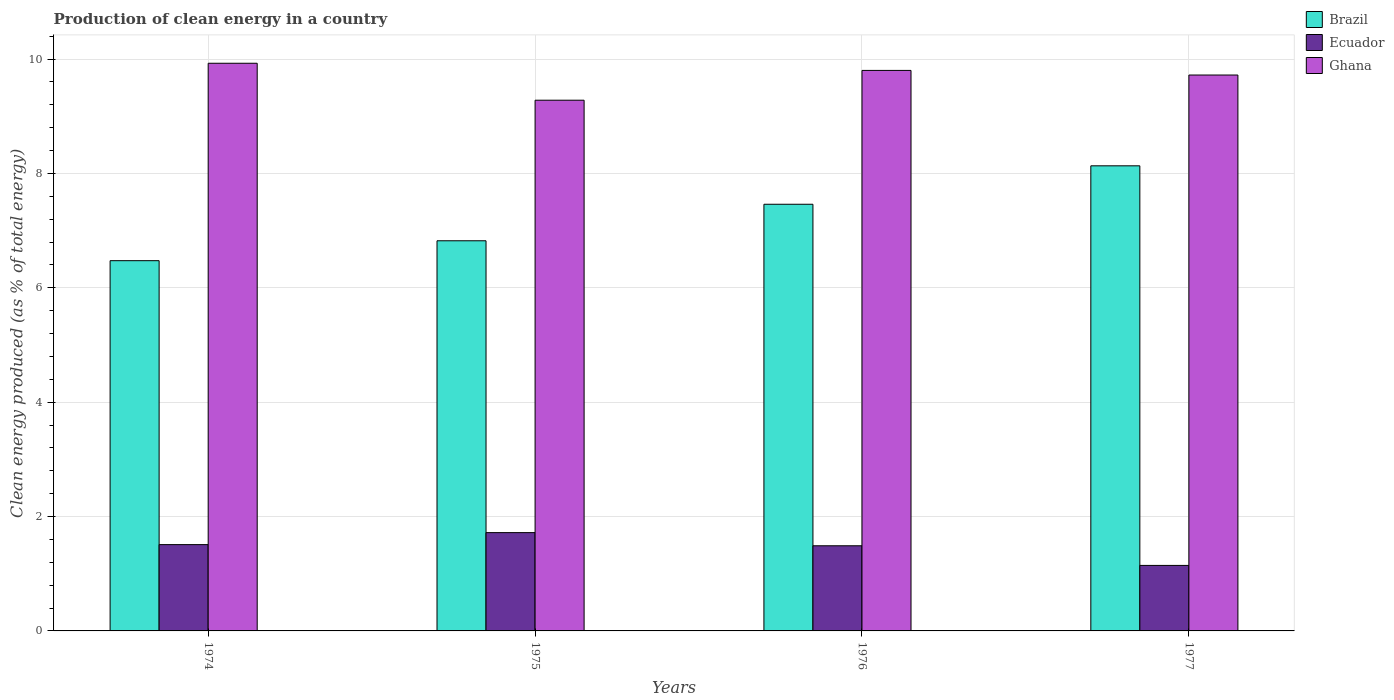How many groups of bars are there?
Ensure brevity in your answer.  4. Are the number of bars on each tick of the X-axis equal?
Your answer should be compact. Yes. How many bars are there on the 1st tick from the left?
Your response must be concise. 3. How many bars are there on the 1st tick from the right?
Provide a succinct answer. 3. What is the label of the 2nd group of bars from the left?
Your response must be concise. 1975. In how many cases, is the number of bars for a given year not equal to the number of legend labels?
Ensure brevity in your answer.  0. What is the percentage of clean energy produced in Ecuador in 1976?
Keep it short and to the point. 1.49. Across all years, what is the maximum percentage of clean energy produced in Ghana?
Your answer should be compact. 9.93. Across all years, what is the minimum percentage of clean energy produced in Ecuador?
Your answer should be compact. 1.15. In which year was the percentage of clean energy produced in Brazil maximum?
Your answer should be compact. 1977. In which year was the percentage of clean energy produced in Brazil minimum?
Offer a terse response. 1974. What is the total percentage of clean energy produced in Ecuador in the graph?
Give a very brief answer. 5.86. What is the difference between the percentage of clean energy produced in Ecuador in 1975 and that in 1977?
Keep it short and to the point. 0.57. What is the difference between the percentage of clean energy produced in Brazil in 1975 and the percentage of clean energy produced in Ghana in 1976?
Keep it short and to the point. -2.98. What is the average percentage of clean energy produced in Ghana per year?
Provide a succinct answer. 9.68. In the year 1975, what is the difference between the percentage of clean energy produced in Ecuador and percentage of clean energy produced in Ghana?
Provide a short and direct response. -7.56. In how many years, is the percentage of clean energy produced in Ecuador greater than 7.6 %?
Give a very brief answer. 0. What is the ratio of the percentage of clean energy produced in Brazil in 1976 to that in 1977?
Ensure brevity in your answer.  0.92. Is the difference between the percentage of clean energy produced in Ecuador in 1974 and 1977 greater than the difference between the percentage of clean energy produced in Ghana in 1974 and 1977?
Give a very brief answer. Yes. What is the difference between the highest and the second highest percentage of clean energy produced in Ecuador?
Ensure brevity in your answer.  0.21. What is the difference between the highest and the lowest percentage of clean energy produced in Ghana?
Offer a terse response. 0.65. In how many years, is the percentage of clean energy produced in Brazil greater than the average percentage of clean energy produced in Brazil taken over all years?
Make the answer very short. 2. What does the 3rd bar from the left in 1975 represents?
Offer a very short reply. Ghana. What does the 2nd bar from the right in 1976 represents?
Provide a succinct answer. Ecuador. Is it the case that in every year, the sum of the percentage of clean energy produced in Ecuador and percentage of clean energy produced in Brazil is greater than the percentage of clean energy produced in Ghana?
Your response must be concise. No. How many years are there in the graph?
Your answer should be compact. 4. Are the values on the major ticks of Y-axis written in scientific E-notation?
Keep it short and to the point. No. Does the graph contain any zero values?
Your answer should be compact. No. Where does the legend appear in the graph?
Offer a very short reply. Top right. What is the title of the graph?
Offer a terse response. Production of clean energy in a country. Does "Mali" appear as one of the legend labels in the graph?
Your answer should be compact. No. What is the label or title of the X-axis?
Give a very brief answer. Years. What is the label or title of the Y-axis?
Provide a short and direct response. Clean energy produced (as % of total energy). What is the Clean energy produced (as % of total energy) of Brazil in 1974?
Provide a succinct answer. 6.47. What is the Clean energy produced (as % of total energy) in Ecuador in 1974?
Make the answer very short. 1.51. What is the Clean energy produced (as % of total energy) of Ghana in 1974?
Provide a short and direct response. 9.93. What is the Clean energy produced (as % of total energy) of Brazil in 1975?
Provide a succinct answer. 6.82. What is the Clean energy produced (as % of total energy) in Ecuador in 1975?
Provide a succinct answer. 1.72. What is the Clean energy produced (as % of total energy) in Ghana in 1975?
Your response must be concise. 9.28. What is the Clean energy produced (as % of total energy) in Brazil in 1976?
Offer a very short reply. 7.46. What is the Clean energy produced (as % of total energy) of Ecuador in 1976?
Provide a short and direct response. 1.49. What is the Clean energy produced (as % of total energy) in Ghana in 1976?
Your response must be concise. 9.8. What is the Clean energy produced (as % of total energy) in Brazil in 1977?
Give a very brief answer. 8.13. What is the Clean energy produced (as % of total energy) in Ecuador in 1977?
Give a very brief answer. 1.15. What is the Clean energy produced (as % of total energy) of Ghana in 1977?
Provide a succinct answer. 9.72. Across all years, what is the maximum Clean energy produced (as % of total energy) of Brazil?
Make the answer very short. 8.13. Across all years, what is the maximum Clean energy produced (as % of total energy) in Ecuador?
Your answer should be compact. 1.72. Across all years, what is the maximum Clean energy produced (as % of total energy) of Ghana?
Your answer should be compact. 9.93. Across all years, what is the minimum Clean energy produced (as % of total energy) in Brazil?
Your answer should be very brief. 6.47. Across all years, what is the minimum Clean energy produced (as % of total energy) in Ecuador?
Your response must be concise. 1.15. Across all years, what is the minimum Clean energy produced (as % of total energy) in Ghana?
Provide a short and direct response. 9.28. What is the total Clean energy produced (as % of total energy) in Brazil in the graph?
Your answer should be compact. 28.89. What is the total Clean energy produced (as % of total energy) of Ecuador in the graph?
Offer a very short reply. 5.86. What is the total Clean energy produced (as % of total energy) of Ghana in the graph?
Your answer should be compact. 38.73. What is the difference between the Clean energy produced (as % of total energy) in Brazil in 1974 and that in 1975?
Give a very brief answer. -0.35. What is the difference between the Clean energy produced (as % of total energy) in Ecuador in 1974 and that in 1975?
Offer a terse response. -0.21. What is the difference between the Clean energy produced (as % of total energy) in Ghana in 1974 and that in 1975?
Offer a very short reply. 0.65. What is the difference between the Clean energy produced (as % of total energy) in Brazil in 1974 and that in 1976?
Offer a terse response. -0.99. What is the difference between the Clean energy produced (as % of total energy) in Ecuador in 1974 and that in 1976?
Provide a succinct answer. 0.02. What is the difference between the Clean energy produced (as % of total energy) in Ghana in 1974 and that in 1976?
Offer a very short reply. 0.13. What is the difference between the Clean energy produced (as % of total energy) in Brazil in 1974 and that in 1977?
Provide a succinct answer. -1.66. What is the difference between the Clean energy produced (as % of total energy) in Ecuador in 1974 and that in 1977?
Keep it short and to the point. 0.36. What is the difference between the Clean energy produced (as % of total energy) in Ghana in 1974 and that in 1977?
Your answer should be compact. 0.21. What is the difference between the Clean energy produced (as % of total energy) in Brazil in 1975 and that in 1976?
Keep it short and to the point. -0.64. What is the difference between the Clean energy produced (as % of total energy) of Ecuador in 1975 and that in 1976?
Your answer should be very brief. 0.23. What is the difference between the Clean energy produced (as % of total energy) in Ghana in 1975 and that in 1976?
Your response must be concise. -0.52. What is the difference between the Clean energy produced (as % of total energy) of Brazil in 1975 and that in 1977?
Provide a succinct answer. -1.31. What is the difference between the Clean energy produced (as % of total energy) of Ecuador in 1975 and that in 1977?
Your answer should be compact. 0.57. What is the difference between the Clean energy produced (as % of total energy) in Ghana in 1975 and that in 1977?
Provide a short and direct response. -0.44. What is the difference between the Clean energy produced (as % of total energy) of Brazil in 1976 and that in 1977?
Provide a succinct answer. -0.67. What is the difference between the Clean energy produced (as % of total energy) of Ecuador in 1976 and that in 1977?
Keep it short and to the point. 0.34. What is the difference between the Clean energy produced (as % of total energy) in Ghana in 1976 and that in 1977?
Provide a succinct answer. 0.08. What is the difference between the Clean energy produced (as % of total energy) in Brazil in 1974 and the Clean energy produced (as % of total energy) in Ecuador in 1975?
Keep it short and to the point. 4.75. What is the difference between the Clean energy produced (as % of total energy) in Brazil in 1974 and the Clean energy produced (as % of total energy) in Ghana in 1975?
Offer a very short reply. -2.81. What is the difference between the Clean energy produced (as % of total energy) of Ecuador in 1974 and the Clean energy produced (as % of total energy) of Ghana in 1975?
Make the answer very short. -7.77. What is the difference between the Clean energy produced (as % of total energy) of Brazil in 1974 and the Clean energy produced (as % of total energy) of Ecuador in 1976?
Your answer should be compact. 4.99. What is the difference between the Clean energy produced (as % of total energy) in Brazil in 1974 and the Clean energy produced (as % of total energy) in Ghana in 1976?
Offer a terse response. -3.33. What is the difference between the Clean energy produced (as % of total energy) of Ecuador in 1974 and the Clean energy produced (as % of total energy) of Ghana in 1976?
Your answer should be compact. -8.29. What is the difference between the Clean energy produced (as % of total energy) in Brazil in 1974 and the Clean energy produced (as % of total energy) in Ecuador in 1977?
Offer a terse response. 5.33. What is the difference between the Clean energy produced (as % of total energy) in Brazil in 1974 and the Clean energy produced (as % of total energy) in Ghana in 1977?
Provide a short and direct response. -3.25. What is the difference between the Clean energy produced (as % of total energy) of Ecuador in 1974 and the Clean energy produced (as % of total energy) of Ghana in 1977?
Offer a very short reply. -8.21. What is the difference between the Clean energy produced (as % of total energy) in Brazil in 1975 and the Clean energy produced (as % of total energy) in Ecuador in 1976?
Offer a very short reply. 5.33. What is the difference between the Clean energy produced (as % of total energy) in Brazil in 1975 and the Clean energy produced (as % of total energy) in Ghana in 1976?
Give a very brief answer. -2.98. What is the difference between the Clean energy produced (as % of total energy) of Ecuador in 1975 and the Clean energy produced (as % of total energy) of Ghana in 1976?
Offer a terse response. -8.08. What is the difference between the Clean energy produced (as % of total energy) of Brazil in 1975 and the Clean energy produced (as % of total energy) of Ecuador in 1977?
Your response must be concise. 5.68. What is the difference between the Clean energy produced (as % of total energy) in Brazil in 1975 and the Clean energy produced (as % of total energy) in Ghana in 1977?
Keep it short and to the point. -2.9. What is the difference between the Clean energy produced (as % of total energy) of Ecuador in 1975 and the Clean energy produced (as % of total energy) of Ghana in 1977?
Your answer should be very brief. -8. What is the difference between the Clean energy produced (as % of total energy) in Brazil in 1976 and the Clean energy produced (as % of total energy) in Ecuador in 1977?
Make the answer very short. 6.31. What is the difference between the Clean energy produced (as % of total energy) of Brazil in 1976 and the Clean energy produced (as % of total energy) of Ghana in 1977?
Your response must be concise. -2.26. What is the difference between the Clean energy produced (as % of total energy) in Ecuador in 1976 and the Clean energy produced (as % of total energy) in Ghana in 1977?
Your answer should be compact. -8.23. What is the average Clean energy produced (as % of total energy) in Brazil per year?
Your answer should be compact. 7.22. What is the average Clean energy produced (as % of total energy) in Ecuador per year?
Your answer should be very brief. 1.47. What is the average Clean energy produced (as % of total energy) in Ghana per year?
Ensure brevity in your answer.  9.68. In the year 1974, what is the difference between the Clean energy produced (as % of total energy) in Brazil and Clean energy produced (as % of total energy) in Ecuador?
Your response must be concise. 4.96. In the year 1974, what is the difference between the Clean energy produced (as % of total energy) of Brazil and Clean energy produced (as % of total energy) of Ghana?
Ensure brevity in your answer.  -3.45. In the year 1974, what is the difference between the Clean energy produced (as % of total energy) in Ecuador and Clean energy produced (as % of total energy) in Ghana?
Offer a terse response. -8.42. In the year 1975, what is the difference between the Clean energy produced (as % of total energy) of Brazil and Clean energy produced (as % of total energy) of Ecuador?
Offer a very short reply. 5.1. In the year 1975, what is the difference between the Clean energy produced (as % of total energy) in Brazil and Clean energy produced (as % of total energy) in Ghana?
Give a very brief answer. -2.46. In the year 1975, what is the difference between the Clean energy produced (as % of total energy) in Ecuador and Clean energy produced (as % of total energy) in Ghana?
Your answer should be very brief. -7.56. In the year 1976, what is the difference between the Clean energy produced (as % of total energy) in Brazil and Clean energy produced (as % of total energy) in Ecuador?
Your response must be concise. 5.97. In the year 1976, what is the difference between the Clean energy produced (as % of total energy) of Brazil and Clean energy produced (as % of total energy) of Ghana?
Ensure brevity in your answer.  -2.34. In the year 1976, what is the difference between the Clean energy produced (as % of total energy) of Ecuador and Clean energy produced (as % of total energy) of Ghana?
Keep it short and to the point. -8.31. In the year 1977, what is the difference between the Clean energy produced (as % of total energy) of Brazil and Clean energy produced (as % of total energy) of Ecuador?
Keep it short and to the point. 6.99. In the year 1977, what is the difference between the Clean energy produced (as % of total energy) in Brazil and Clean energy produced (as % of total energy) in Ghana?
Provide a succinct answer. -1.59. In the year 1977, what is the difference between the Clean energy produced (as % of total energy) of Ecuador and Clean energy produced (as % of total energy) of Ghana?
Give a very brief answer. -8.57. What is the ratio of the Clean energy produced (as % of total energy) of Brazil in 1974 to that in 1975?
Offer a terse response. 0.95. What is the ratio of the Clean energy produced (as % of total energy) in Ecuador in 1974 to that in 1975?
Your answer should be compact. 0.88. What is the ratio of the Clean energy produced (as % of total energy) of Ghana in 1974 to that in 1975?
Make the answer very short. 1.07. What is the ratio of the Clean energy produced (as % of total energy) in Brazil in 1974 to that in 1976?
Keep it short and to the point. 0.87. What is the ratio of the Clean energy produced (as % of total energy) in Ecuador in 1974 to that in 1976?
Give a very brief answer. 1.01. What is the ratio of the Clean energy produced (as % of total energy) in Ghana in 1974 to that in 1976?
Keep it short and to the point. 1.01. What is the ratio of the Clean energy produced (as % of total energy) of Brazil in 1974 to that in 1977?
Ensure brevity in your answer.  0.8. What is the ratio of the Clean energy produced (as % of total energy) in Ecuador in 1974 to that in 1977?
Provide a succinct answer. 1.32. What is the ratio of the Clean energy produced (as % of total energy) of Ghana in 1974 to that in 1977?
Your response must be concise. 1.02. What is the ratio of the Clean energy produced (as % of total energy) in Brazil in 1975 to that in 1976?
Offer a terse response. 0.91. What is the ratio of the Clean energy produced (as % of total energy) in Ecuador in 1975 to that in 1976?
Keep it short and to the point. 1.15. What is the ratio of the Clean energy produced (as % of total energy) of Ghana in 1975 to that in 1976?
Make the answer very short. 0.95. What is the ratio of the Clean energy produced (as % of total energy) in Brazil in 1975 to that in 1977?
Ensure brevity in your answer.  0.84. What is the ratio of the Clean energy produced (as % of total energy) in Ecuador in 1975 to that in 1977?
Provide a short and direct response. 1.5. What is the ratio of the Clean energy produced (as % of total energy) of Ghana in 1975 to that in 1977?
Make the answer very short. 0.95. What is the ratio of the Clean energy produced (as % of total energy) in Brazil in 1976 to that in 1977?
Ensure brevity in your answer.  0.92. What is the ratio of the Clean energy produced (as % of total energy) of Ecuador in 1976 to that in 1977?
Provide a succinct answer. 1.3. What is the ratio of the Clean energy produced (as % of total energy) in Ghana in 1976 to that in 1977?
Keep it short and to the point. 1.01. What is the difference between the highest and the second highest Clean energy produced (as % of total energy) in Brazil?
Your response must be concise. 0.67. What is the difference between the highest and the second highest Clean energy produced (as % of total energy) of Ecuador?
Provide a succinct answer. 0.21. What is the difference between the highest and the second highest Clean energy produced (as % of total energy) in Ghana?
Keep it short and to the point. 0.13. What is the difference between the highest and the lowest Clean energy produced (as % of total energy) in Brazil?
Make the answer very short. 1.66. What is the difference between the highest and the lowest Clean energy produced (as % of total energy) in Ecuador?
Provide a succinct answer. 0.57. What is the difference between the highest and the lowest Clean energy produced (as % of total energy) of Ghana?
Offer a very short reply. 0.65. 